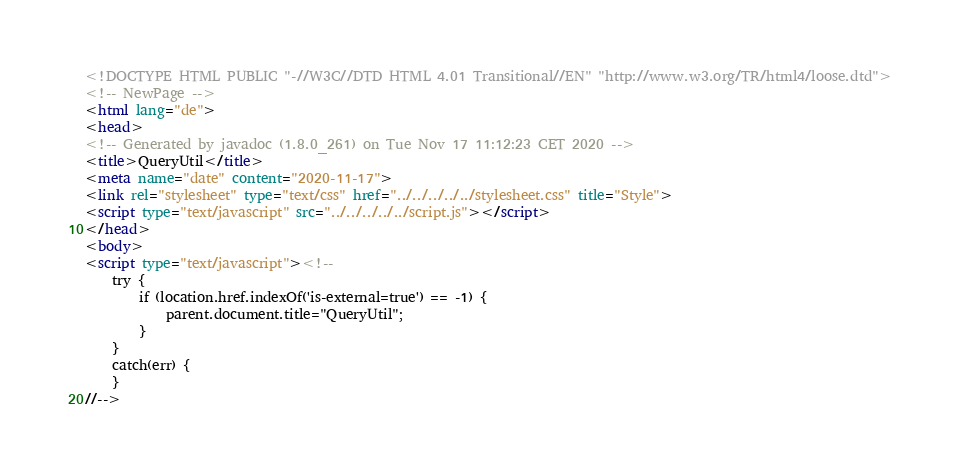<code> <loc_0><loc_0><loc_500><loc_500><_HTML_><!DOCTYPE HTML PUBLIC "-//W3C//DTD HTML 4.01 Transitional//EN" "http://www.w3.org/TR/html4/loose.dtd">
<!-- NewPage -->
<html lang="de">
<head>
<!-- Generated by javadoc (1.8.0_261) on Tue Nov 17 11:12:23 CET 2020 -->
<title>QueryUtil</title>
<meta name="date" content="2020-11-17">
<link rel="stylesheet" type="text/css" href="../../../../../stylesheet.css" title="Style">
<script type="text/javascript" src="../../../../../script.js"></script>
</head>
<body>
<script type="text/javascript"><!--
    try {
        if (location.href.indexOf('is-external=true') == -1) {
            parent.document.title="QueryUtil";
        }
    }
    catch(err) {
    }
//--></code> 